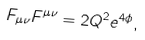Convert formula to latex. <formula><loc_0><loc_0><loc_500><loc_500>F _ { \mu \nu } F ^ { \mu \nu } = 2 Q ^ { 2 } e ^ { 4 \phi } ,</formula> 